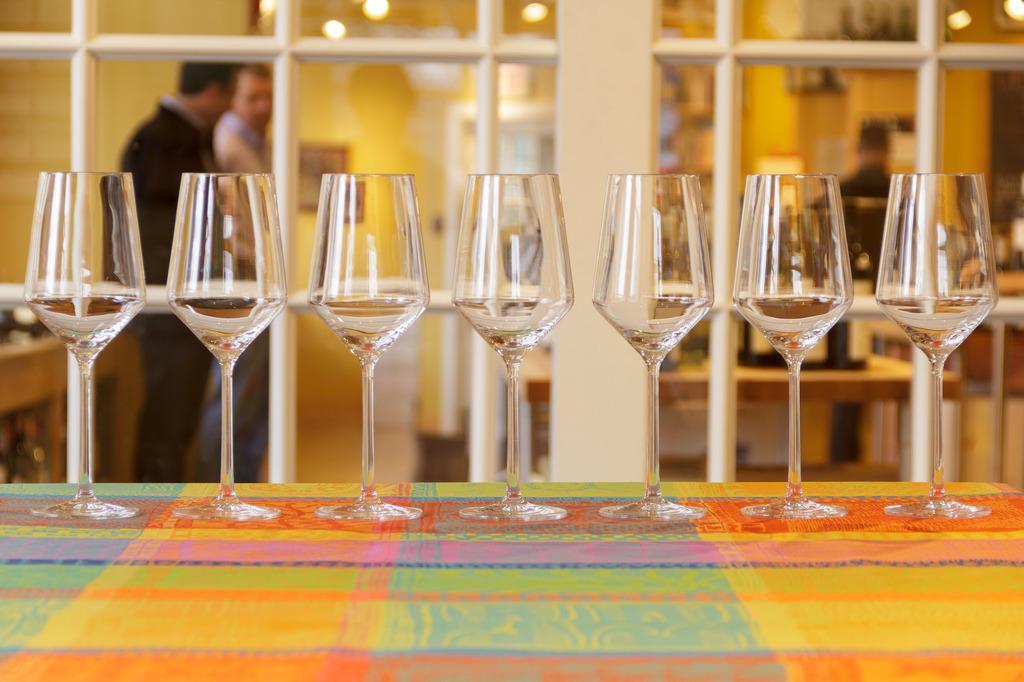How would you summarize this image in a sentence or two? In this image I can see a few glasses on the table. On the table there is a colorful cloth. At the back side I can see two persons. 